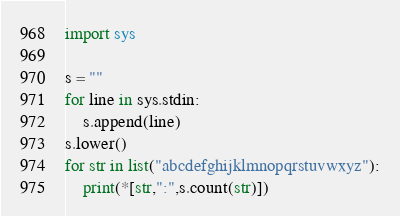Convert code to text. <code><loc_0><loc_0><loc_500><loc_500><_Python_>import sys

s = ""
for line in sys.stdin:
    s.append(line)
s.lower()
for str in list("abcdefghijklmnopqrstuvwxyz"):
    print(*[str,":",s.count(str)])
</code> 